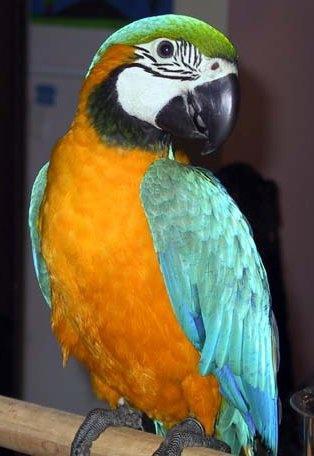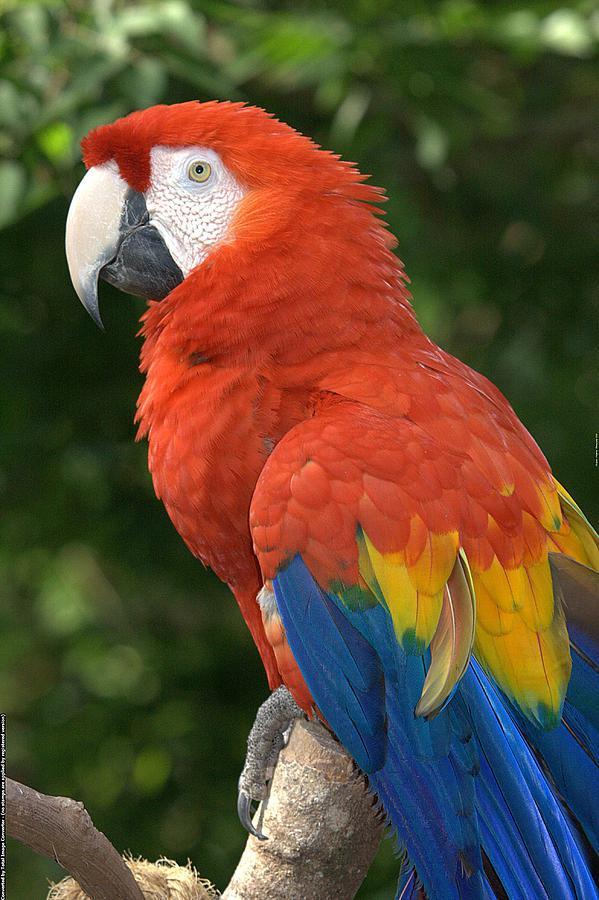The first image is the image on the left, the second image is the image on the right. For the images shown, is this caption "There are no more than three birds" true? Answer yes or no. Yes. 